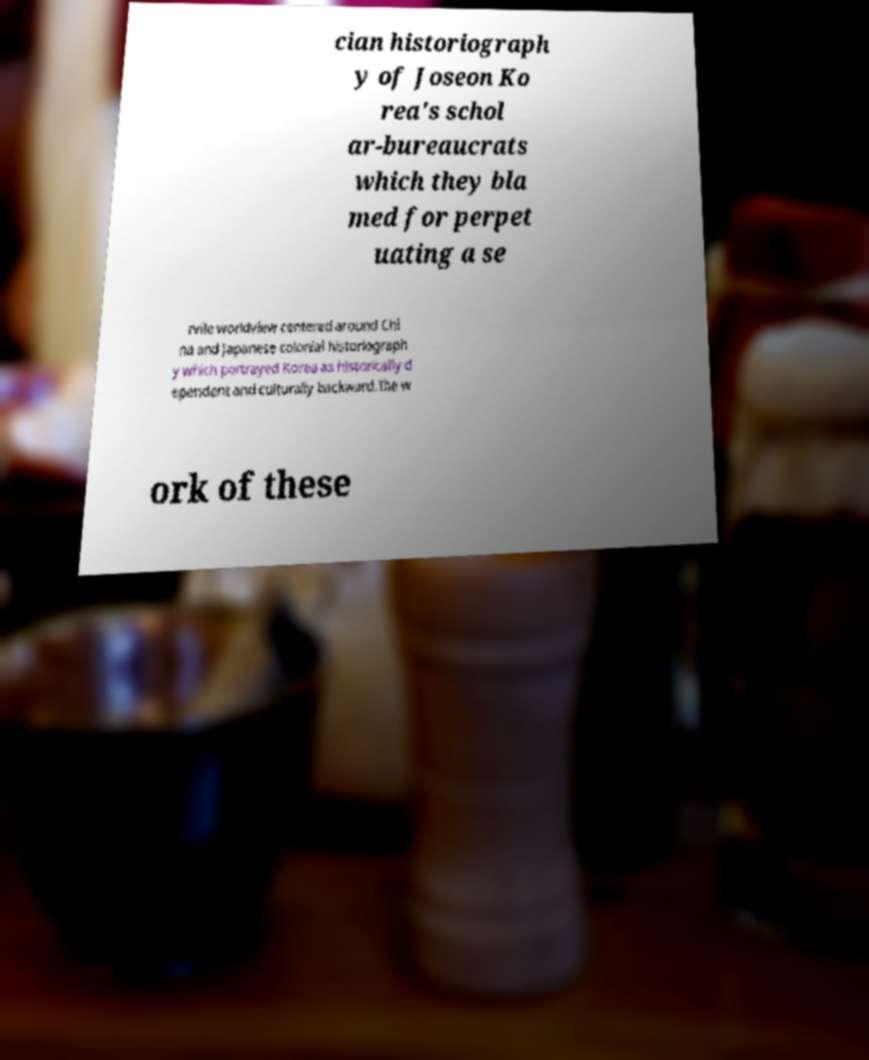Could you extract and type out the text from this image? cian historiograph y of Joseon Ko rea's schol ar-bureaucrats which they bla med for perpet uating a se rvile worldview centered around Chi na and Japanese colonial historiograph y which portrayed Korea as historically d ependent and culturally backward.The w ork of these 